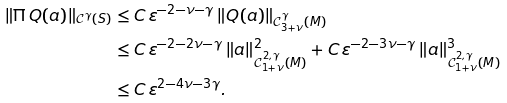<formula> <loc_0><loc_0><loc_500><loc_500>\| \Pi \, Q ( a ) \| _ { \mathcal { C } ^ { \gamma } ( S ) } & \leq C \, \varepsilon ^ { - 2 - \nu - \gamma } \, \| Q ( a ) \| _ { \mathcal { C } _ { 3 + \nu } ^ { \gamma } ( M ) } \\ & \leq C \, \varepsilon ^ { - 2 - 2 \nu - \gamma } \, \| a \| _ { \mathcal { C } _ { 1 + \nu } ^ { 2 , \gamma } ( M ) } ^ { 2 } + C \, \varepsilon ^ { - 2 - 3 \nu - \gamma } \, \| a \| _ { \mathcal { C } _ { 1 + \nu } ^ { 2 , \gamma } ( M ) } ^ { 3 } \\ & \leq C \, \varepsilon ^ { 2 - 4 \nu - 3 \gamma } .</formula> 